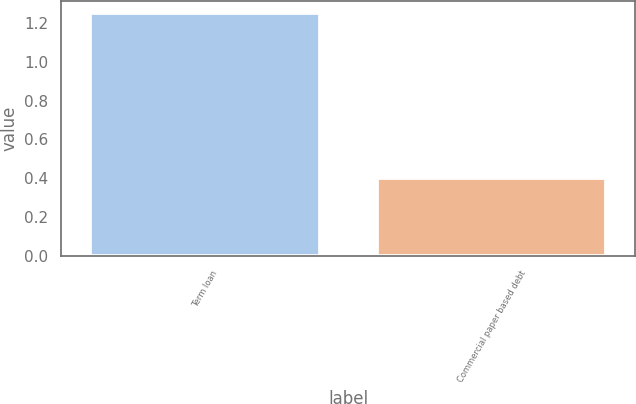Convert chart to OTSL. <chart><loc_0><loc_0><loc_500><loc_500><bar_chart><fcel>Term loan<fcel>Commercial paper based debt<nl><fcel>1.25<fcel>0.4<nl></chart> 